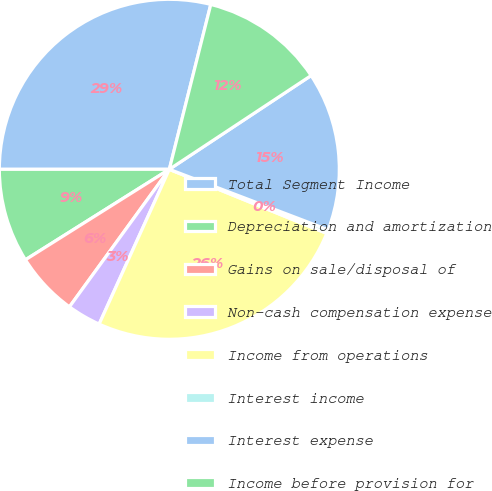Convert chart to OTSL. <chart><loc_0><loc_0><loc_500><loc_500><pie_chart><fcel>Total Segment Income<fcel>Depreciation and amortization<fcel>Gains on sale/disposal of<fcel>Non-cash compensation expense<fcel>Income from operations<fcel>Interest income<fcel>Interest expense<fcel>Income before provision for<nl><fcel>28.92%<fcel>8.93%<fcel>6.07%<fcel>3.22%<fcel>25.62%<fcel>0.36%<fcel>15.09%<fcel>11.78%<nl></chart> 